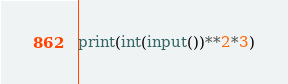<code> <loc_0><loc_0><loc_500><loc_500><_Python_>print(int(input())**2*3)</code> 